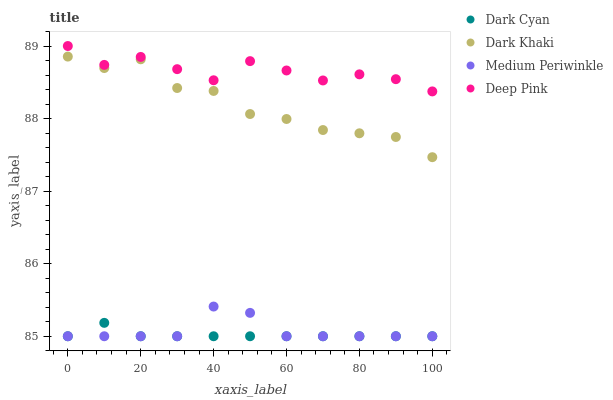Does Dark Cyan have the minimum area under the curve?
Answer yes or no. Yes. Does Deep Pink have the maximum area under the curve?
Answer yes or no. Yes. Does Dark Khaki have the minimum area under the curve?
Answer yes or no. No. Does Dark Khaki have the maximum area under the curve?
Answer yes or no. No. Is Dark Cyan the smoothest?
Answer yes or no. Yes. Is Dark Khaki the roughest?
Answer yes or no. Yes. Is Deep Pink the smoothest?
Answer yes or no. No. Is Deep Pink the roughest?
Answer yes or no. No. Does Dark Cyan have the lowest value?
Answer yes or no. Yes. Does Dark Khaki have the lowest value?
Answer yes or no. No. Does Deep Pink have the highest value?
Answer yes or no. Yes. Does Dark Khaki have the highest value?
Answer yes or no. No. Is Dark Cyan less than Dark Khaki?
Answer yes or no. Yes. Is Deep Pink greater than Dark Khaki?
Answer yes or no. Yes. Does Medium Periwinkle intersect Dark Cyan?
Answer yes or no. Yes. Is Medium Periwinkle less than Dark Cyan?
Answer yes or no. No. Is Medium Periwinkle greater than Dark Cyan?
Answer yes or no. No. Does Dark Cyan intersect Dark Khaki?
Answer yes or no. No. 